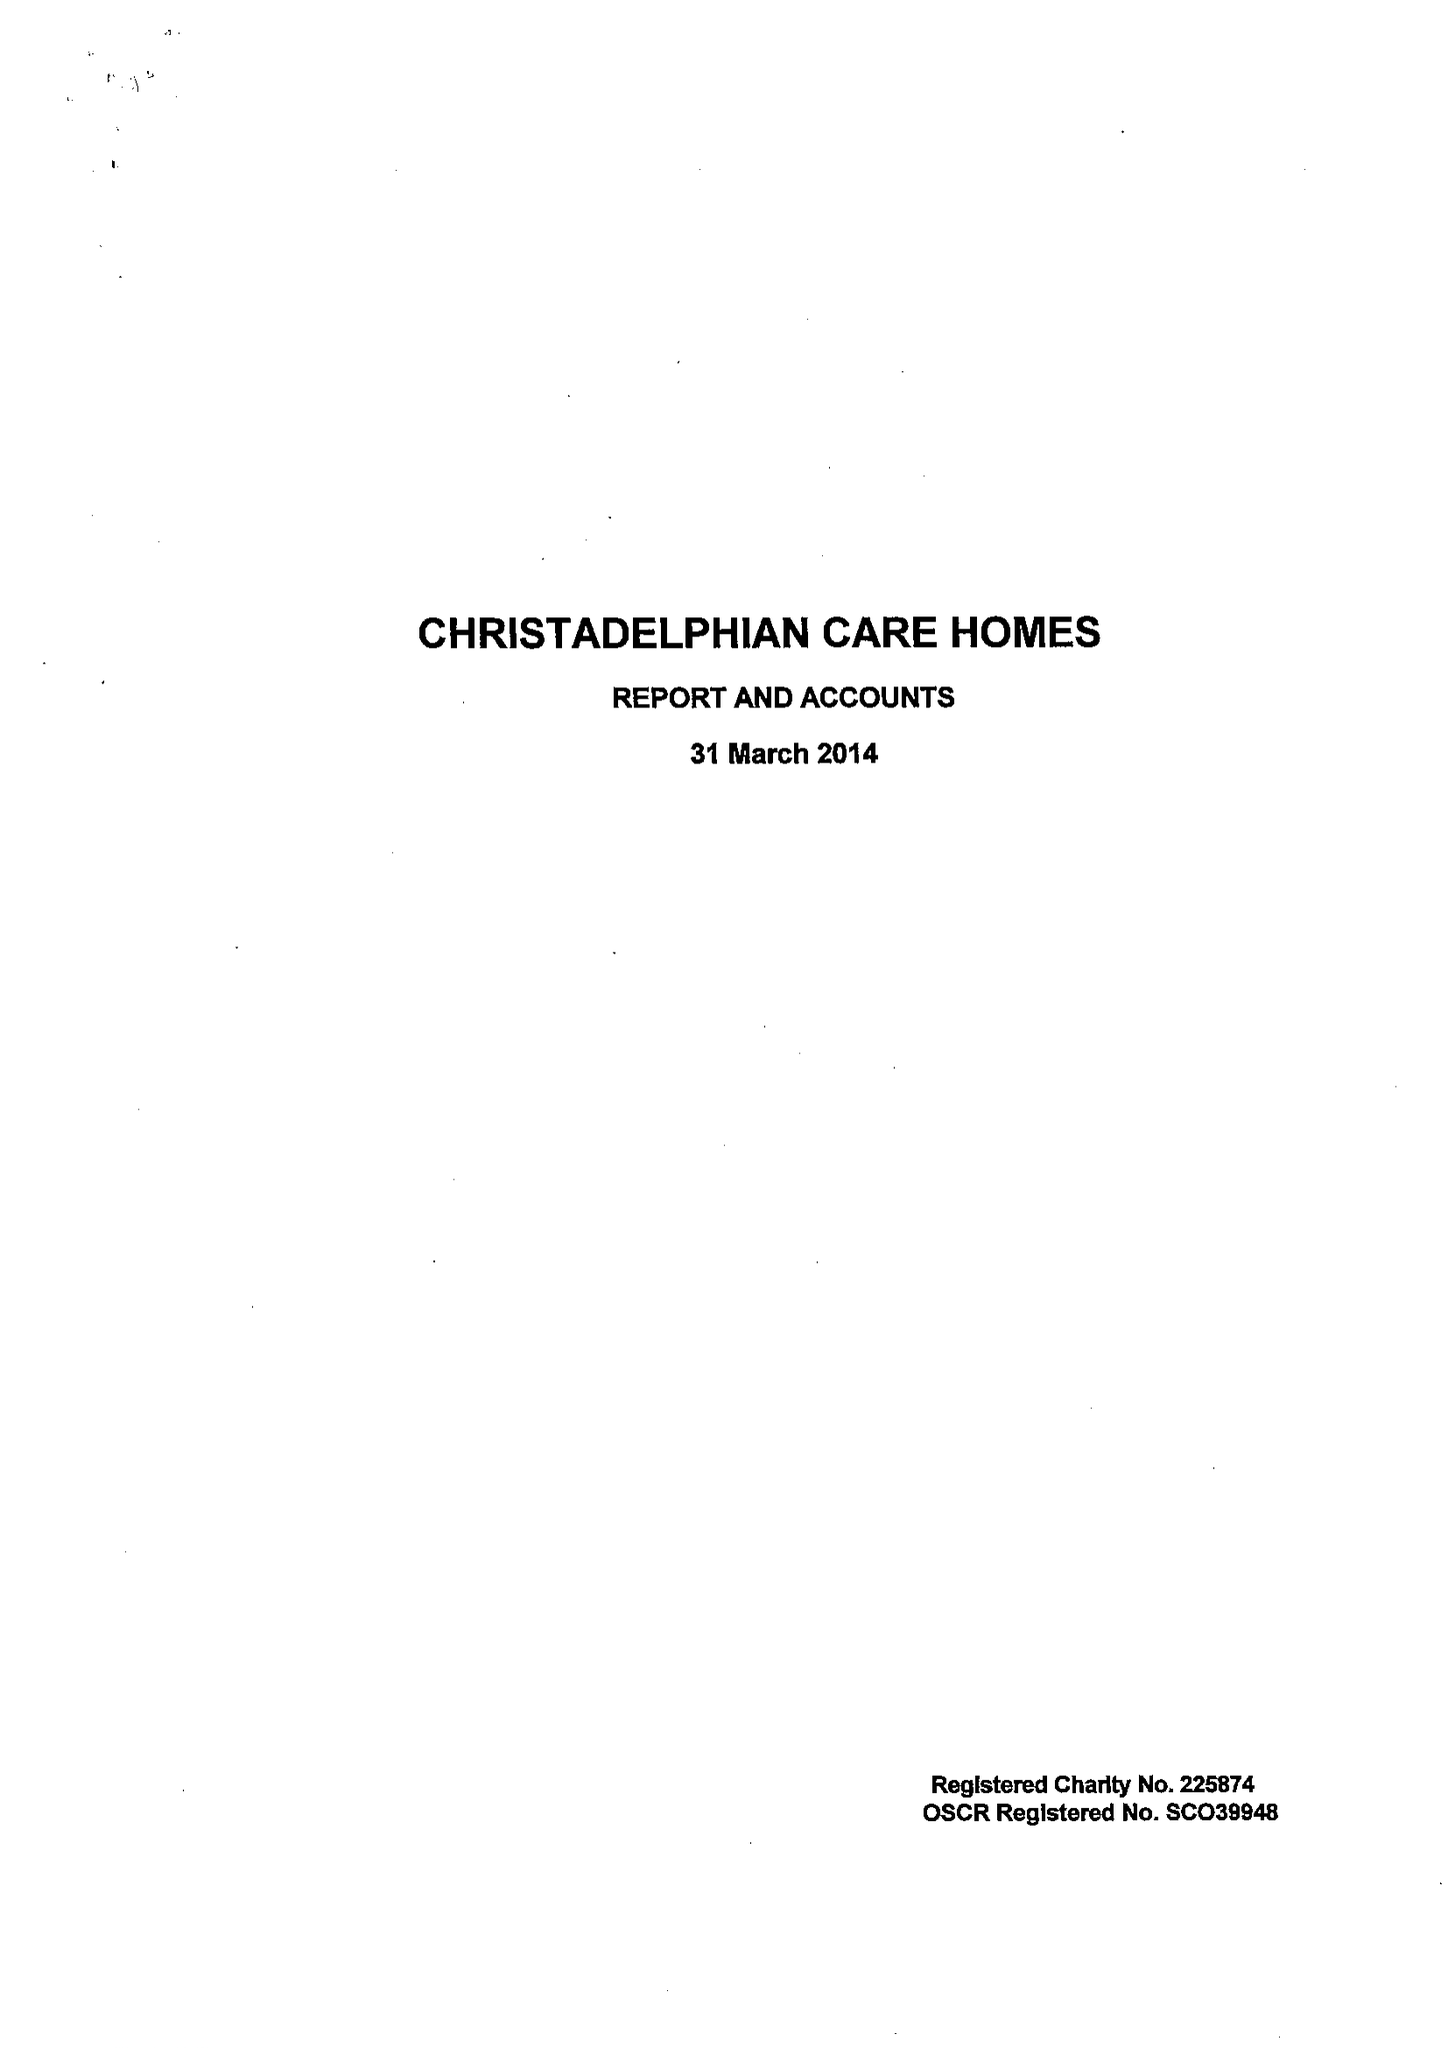What is the value for the address__street_line?
Answer the question using a single word or phrase. 17 SHERBOURNE ROAD 